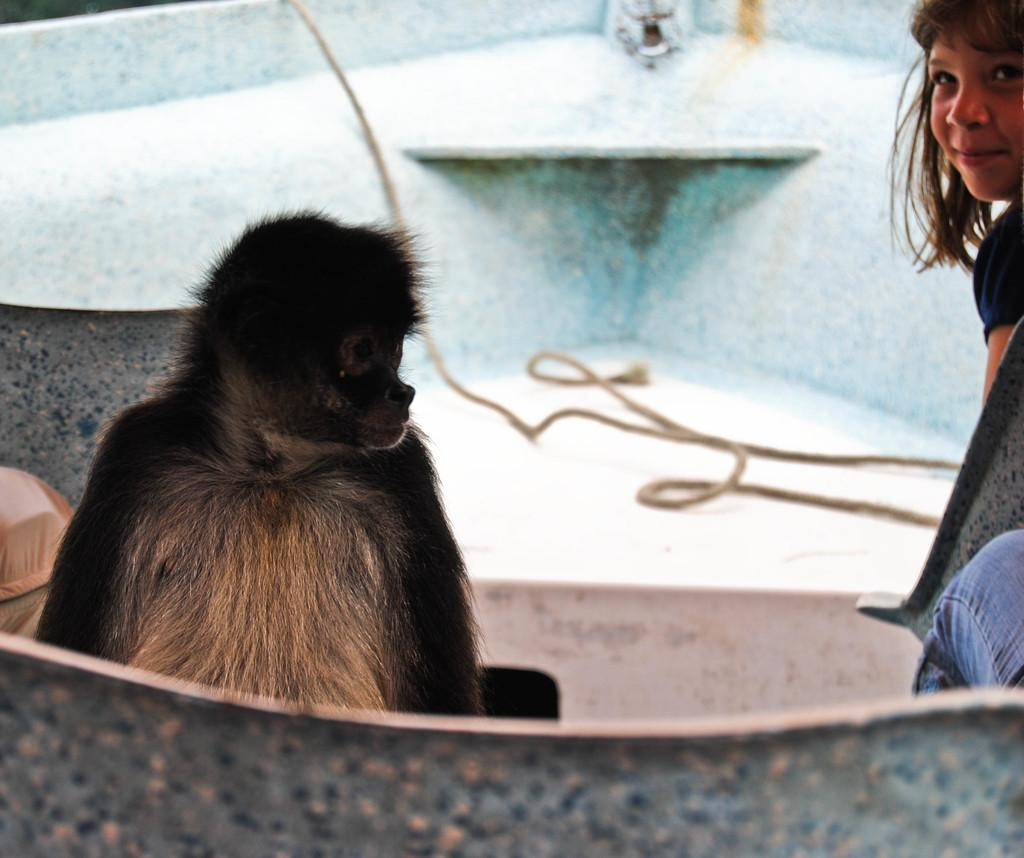What type of animal is in the image? There is a monkey in the image. Who else is present in the image? There is a kid in the image. What object can be seen in the image that might be used for climbing or swinging? There is a rope visible in the image. What is the price of the monkey in the image? There is no price mentioned or implied in the image, as it is not a commercial transaction. 